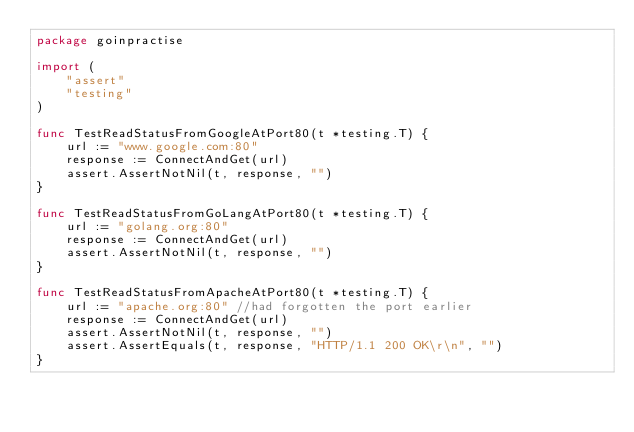Convert code to text. <code><loc_0><loc_0><loc_500><loc_500><_Go_>package goinpractise

import (
	"assert"
	"testing"
)

func TestReadStatusFromGoogleAtPort80(t *testing.T) {
	url := "www.google.com:80"
	response := ConnectAndGet(url)
	assert.AssertNotNil(t, response, "")
}

func TestReadStatusFromGoLangAtPort80(t *testing.T) {
	url := "golang.org:80"
	response := ConnectAndGet(url)
	assert.AssertNotNil(t, response, "")
}

func TestReadStatusFromApacheAtPort80(t *testing.T) {
	url := "apache.org:80" //had forgotten the port earlier
	response := ConnectAndGet(url)
	assert.AssertNotNil(t, response, "")
	assert.AssertEquals(t, response, "HTTP/1.1 200 OK\r\n", "")
}
</code> 